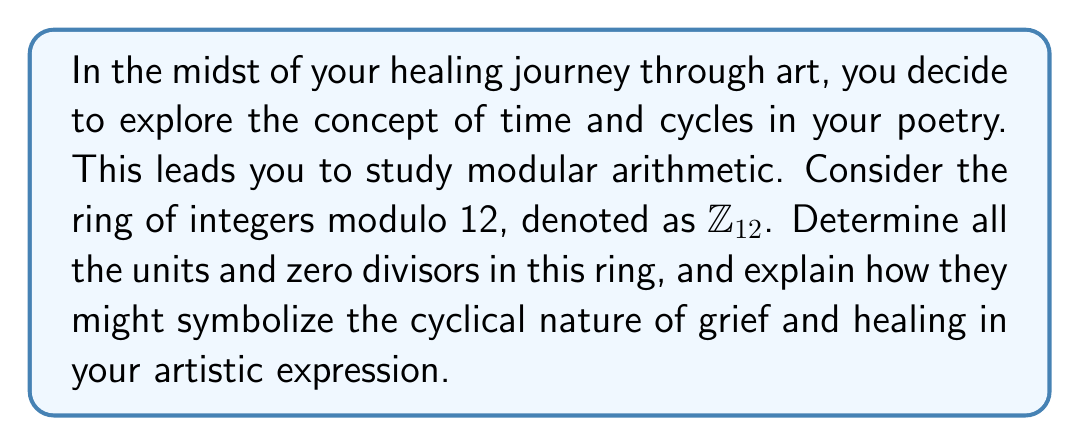Teach me how to tackle this problem. To solve this problem, let's follow these steps:

1) First, recall that in a ring $\mathbb{Z}_n$:
   - A unit is an element $a$ such that there exists a $b$ where $ab \equiv 1 \pmod{n}$
   - A zero divisor is a non-zero element $a$ such that there exists a non-zero $b$ where $ab \equiv 0 \pmod{n}$

2) For $\mathbb{Z}_{12}$, we need to check each element from 0 to 11.

3) To find units:
   - 1 is always a unit (1 * 1 ≡ 1 mod 12)
   - 5 is a unit (5 * 5 ≡ 1 mod 12)
   - 7 is a unit (7 * 7 ≡ 1 mod 12)
   - 11 is a unit (11 * 11 ≡ 1 mod 12)

4) To find zero divisors:
   - 2 * 6 ≡ 0 mod 12, so 2 and 6 are zero divisors
   - 3 * 4 ≡ 0 mod 12, so 3 and 4 are zero divisors
   - 8 * 3 ≡ 0 mod 12, so 8 is a zero divisor (3 was already counted)
   - 9 * 4 ≡ 0 mod 12, so 9 is a zero divisor (4 was already counted)
   - 10 * 6 ≡ 0 mod 12, so 10 is a zero divisor (6 was already counted)

5) 0 is neither a unit nor a zero divisor by definition.

In the context of the persona's artistic expression:
- The units (1, 5, 7, 11) could symbolize moments of strength and resilience in the healing journey, as they have unique inverses and maintain their identity within the cycle.
- The zero divisors (2, 3, 4, 6, 8, 9, 10) might represent the complex, sometimes nullifying interactions of emotions during the grieving process.
- The cyclical nature of $\mathbb{Z}_{12}$ itself could represent the recurring patterns of emotions and memories throughout the healing process.
Answer: Units in $\mathbb{Z}_{12}$: $\{1, 5, 7, 11\}$
Zero divisors in $\mathbb{Z}_{12}$: $\{2, 3, 4, 6, 8, 9, 10\}$ 